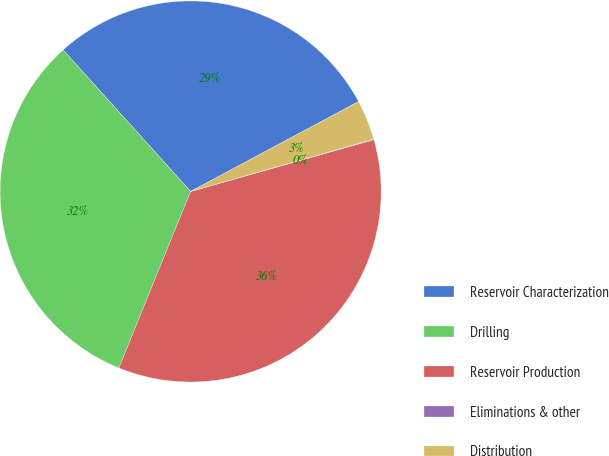Convert chart. <chart><loc_0><loc_0><loc_500><loc_500><pie_chart><fcel>Reservoir Characterization<fcel>Drilling<fcel>Reservoir Production<fcel>Eliminations & other<fcel>Distribution<nl><fcel>28.85%<fcel>32.19%<fcel>35.53%<fcel>0.05%<fcel>3.39%<nl></chart> 